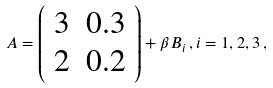<formula> <loc_0><loc_0><loc_500><loc_500>A = \left ( \begin{array} { c c } 3 & 0 . 3 \\ 2 & 0 . 2 \end{array} \right ) + \beta B _ { i } \, , i = 1 , 2 , 3 \, ,</formula> 